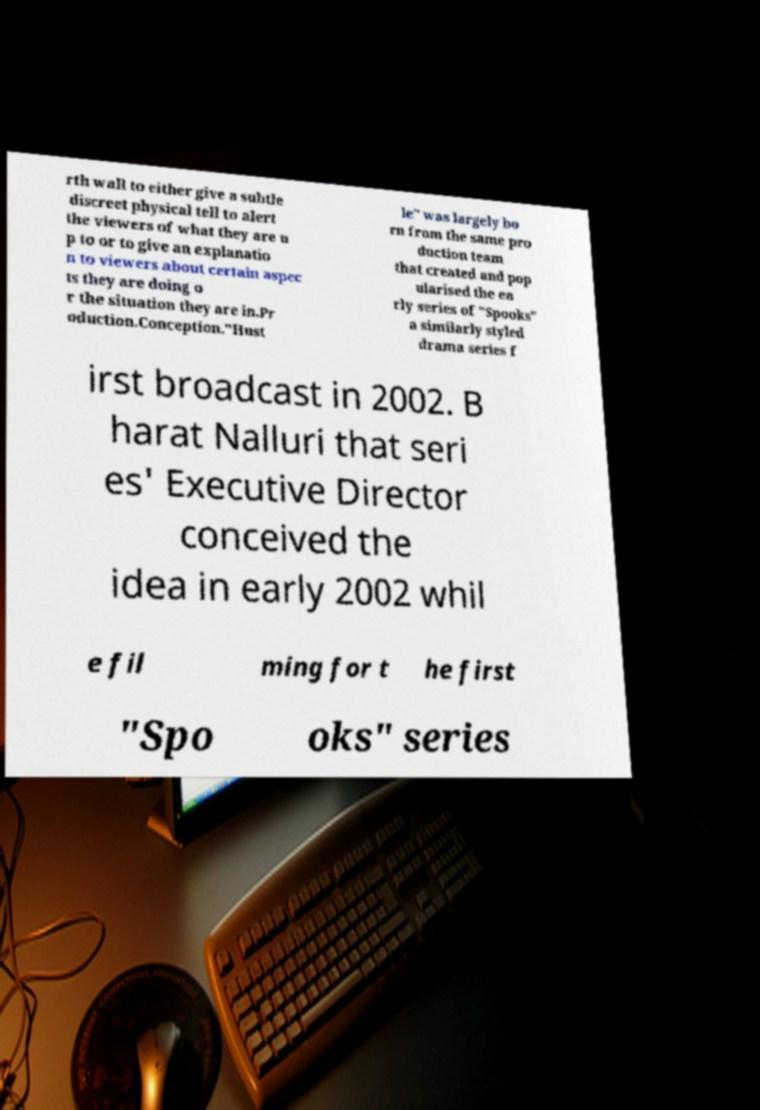Could you assist in decoding the text presented in this image and type it out clearly? rth wall to either give a subtle discreet physical tell to alert the viewers of what they are u p to or to give an explanatio n to viewers about certain aspec ts they are doing o r the situation they are in.Pr oduction.Conception."Hust le" was largely bo rn from the same pro duction team that created and pop ularised the ea rly series of "Spooks" a similarly styled drama series f irst broadcast in 2002. B harat Nalluri that seri es' Executive Director conceived the idea in early 2002 whil e fil ming for t he first "Spo oks" series 